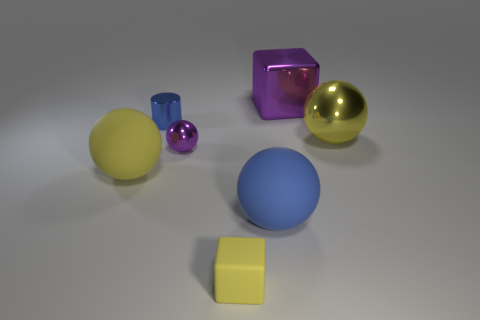How many yellow spheres must be subtracted to get 1 yellow spheres? 1 Subtract all purple balls. How many balls are left? 3 Subtract all gray balls. Subtract all red cylinders. How many balls are left? 4 Add 1 tiny green cubes. How many objects exist? 8 Subtract all spheres. How many objects are left? 3 Add 1 yellow rubber blocks. How many yellow rubber blocks are left? 2 Add 2 small cubes. How many small cubes exist? 3 Subtract 1 purple balls. How many objects are left? 6 Subtract all large purple rubber cylinders. Subtract all yellow blocks. How many objects are left? 6 